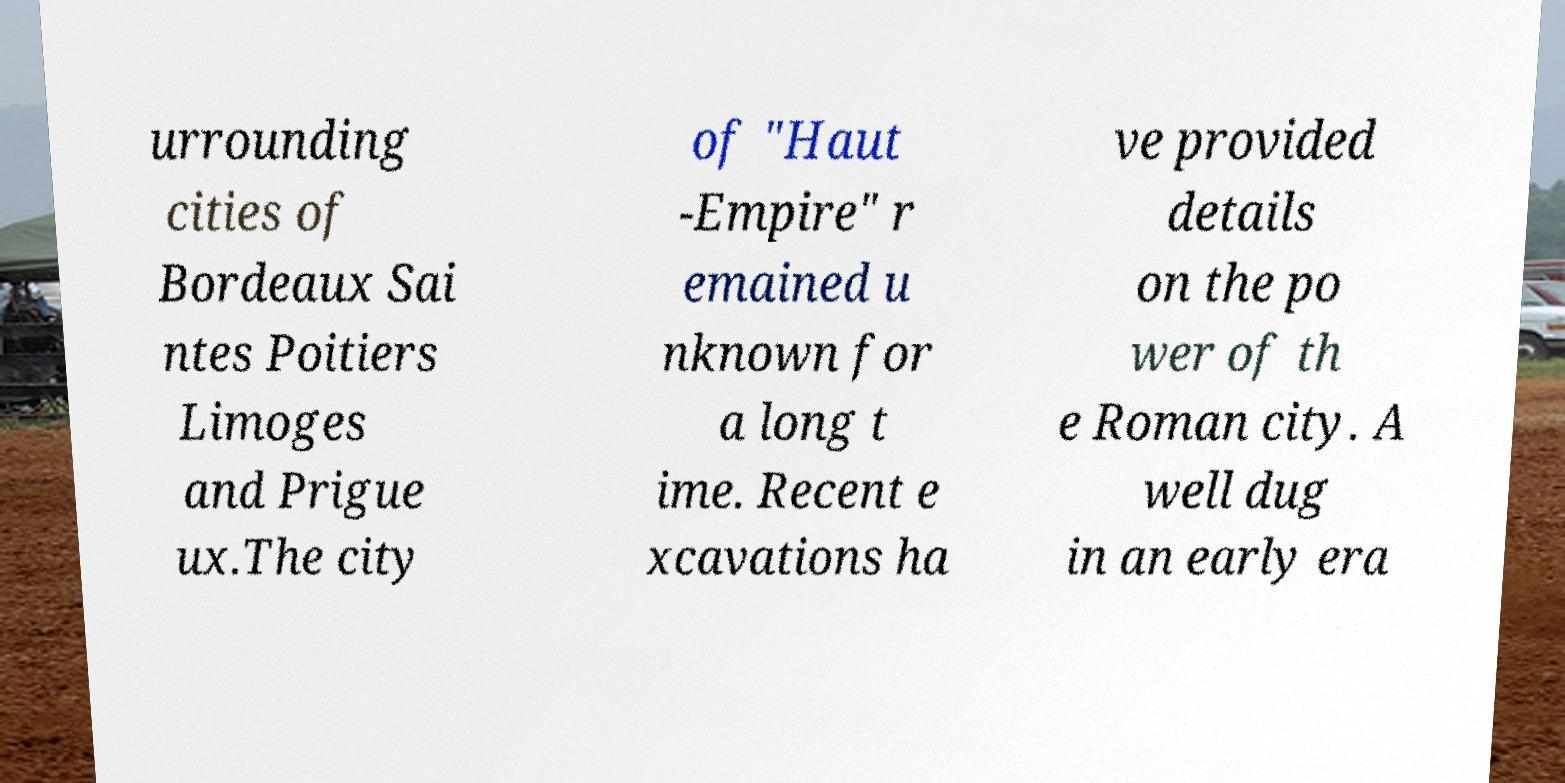For documentation purposes, I need the text within this image transcribed. Could you provide that? urrounding cities of Bordeaux Sai ntes Poitiers Limoges and Prigue ux.The city of "Haut -Empire" r emained u nknown for a long t ime. Recent e xcavations ha ve provided details on the po wer of th e Roman city. A well dug in an early era 